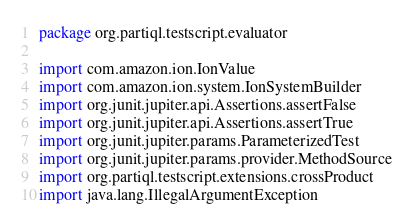Convert code to text. <code><loc_0><loc_0><loc_500><loc_500><_Kotlin_>package org.partiql.testscript.evaluator

import com.amazon.ion.IonValue
import com.amazon.ion.system.IonSystemBuilder
import org.junit.jupiter.api.Assertions.assertFalse
import org.junit.jupiter.api.Assertions.assertTrue
import org.junit.jupiter.params.ParameterizedTest
import org.junit.jupiter.params.provider.MethodSource
import org.partiql.testscript.extensions.crossProduct
import java.lang.IllegalArgumentException</code> 